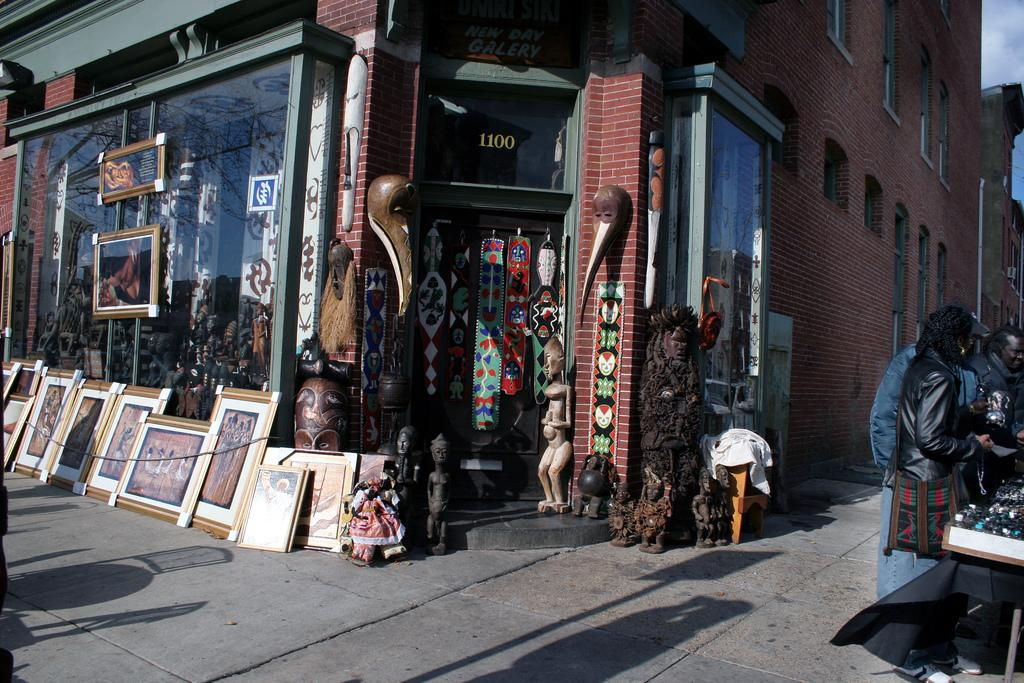What can be seen in the image that has a frame? There are frames in the image, which likely contain artwork or photographs. What type of structures are depicted with windows in the image? There are buildings with windows in the image. What is the purpose of the pipe in the image? The purpose of the pipe in the image is not clear, but it could be part of a plumbing or ventilation system. What are the people in the image doing? The people standing on the ground in the image are likely observing the surroundings or interacting with the sculptures. What type of artistic objects can be seen in the image? There are sculptures in the image. What can be seen in the background of the image? The sky with clouds is visible in the background of the image. How many minutes does it take for the mother to appear in the image? There is no mention of a mother or any time-related information in the image, so this question cannot be answered. 